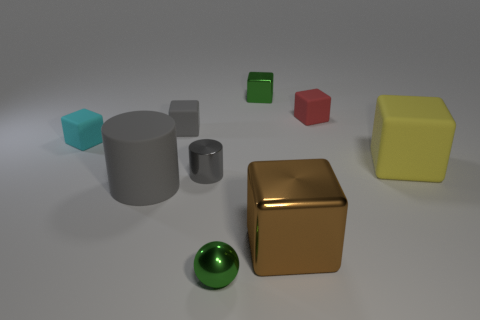Subtract all red cubes. How many cubes are left? 5 Add 1 yellow cubes. How many objects exist? 10 Subtract all yellow blocks. How many blocks are left? 5 Subtract all cylinders. How many objects are left? 7 Subtract all gray cubes. Subtract all yellow balls. How many cubes are left? 5 Subtract all small green shiny spheres. Subtract all gray shiny cylinders. How many objects are left? 7 Add 4 large brown cubes. How many large brown cubes are left? 5 Add 2 tiny gray matte objects. How many tiny gray matte objects exist? 3 Subtract 1 cyan cubes. How many objects are left? 8 